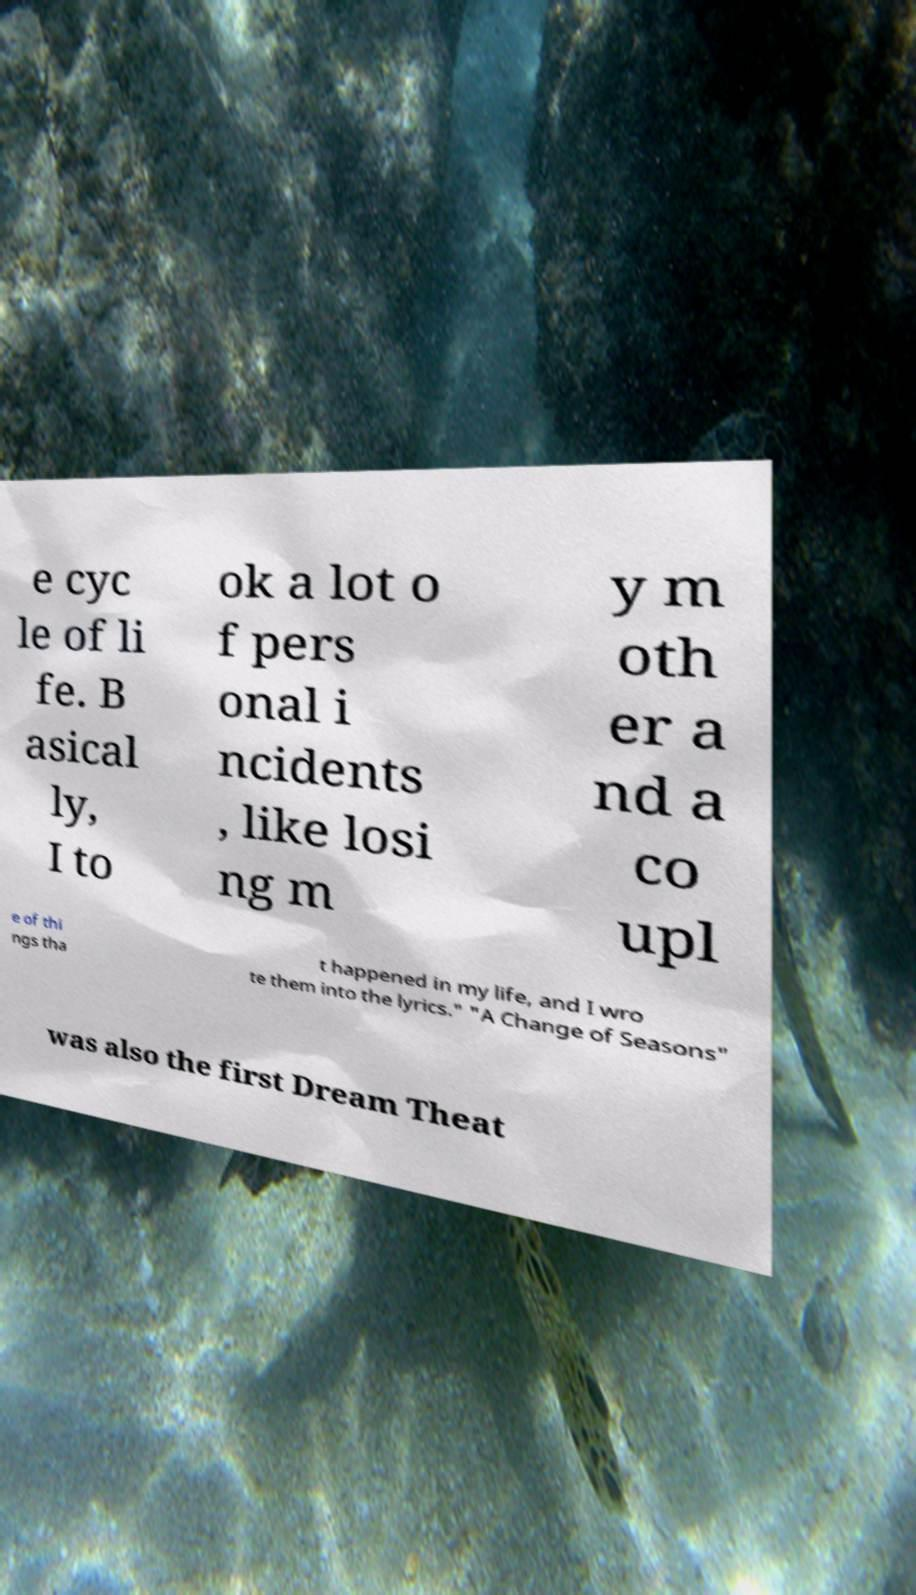Could you assist in decoding the text presented in this image and type it out clearly? e cyc le of li fe. B asical ly, I to ok a lot o f pers onal i ncidents , like losi ng m y m oth er a nd a co upl e of thi ngs tha t happened in my life, and I wro te them into the lyrics." "A Change of Seasons" was also the first Dream Theat 